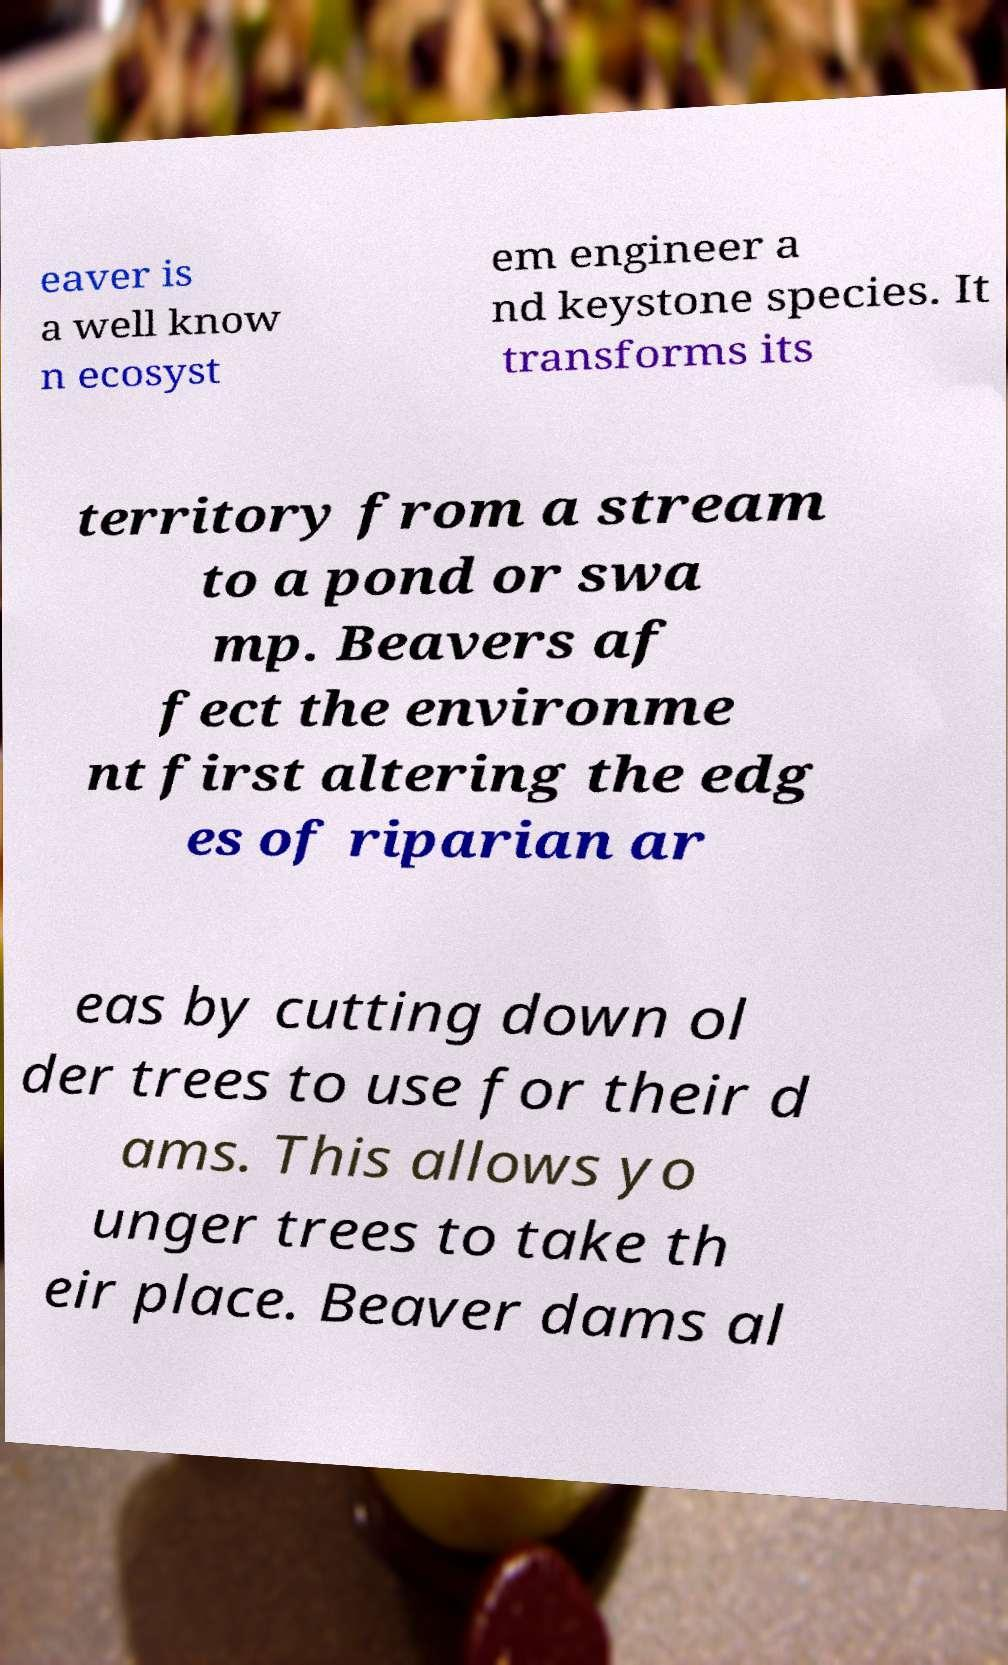For documentation purposes, I need the text within this image transcribed. Could you provide that? eaver is a well know n ecosyst em engineer a nd keystone species. It transforms its territory from a stream to a pond or swa mp. Beavers af fect the environme nt first altering the edg es of riparian ar eas by cutting down ol der trees to use for their d ams. This allows yo unger trees to take th eir place. Beaver dams al 